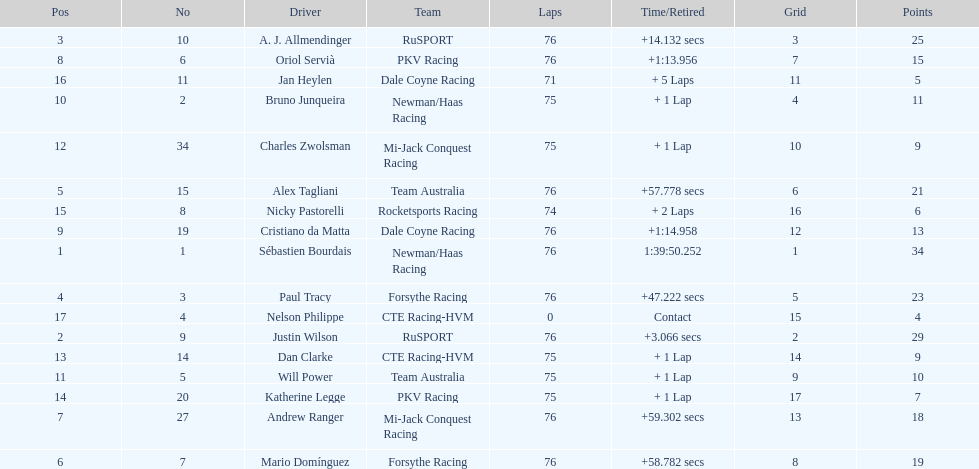How many positions are held by canada? 3. 